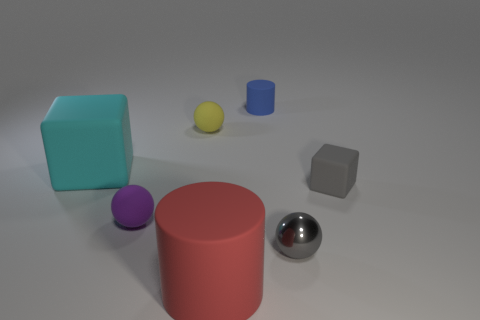There is another matte sphere that is the same size as the purple matte ball; what color is it? yellow 